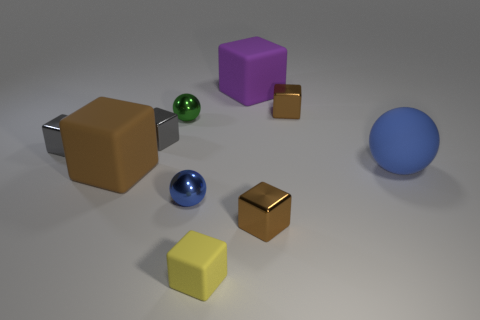Subtract all cyan cylinders. How many brown cubes are left? 3 Subtract all yellow blocks. How many blocks are left? 6 Subtract all small yellow cubes. How many cubes are left? 6 Subtract all red cubes. Subtract all gray spheres. How many cubes are left? 7 Subtract all balls. How many objects are left? 7 Add 6 blue metallic balls. How many blue metallic balls are left? 7 Add 2 big brown rubber cubes. How many big brown rubber cubes exist? 3 Subtract 0 blue cubes. How many objects are left? 10 Subtract all purple cylinders. Subtract all blue metal objects. How many objects are left? 9 